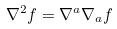Convert formula to latex. <formula><loc_0><loc_0><loc_500><loc_500>\nabla ^ { 2 } f = \nabla ^ { a } \nabla _ { a } f</formula> 